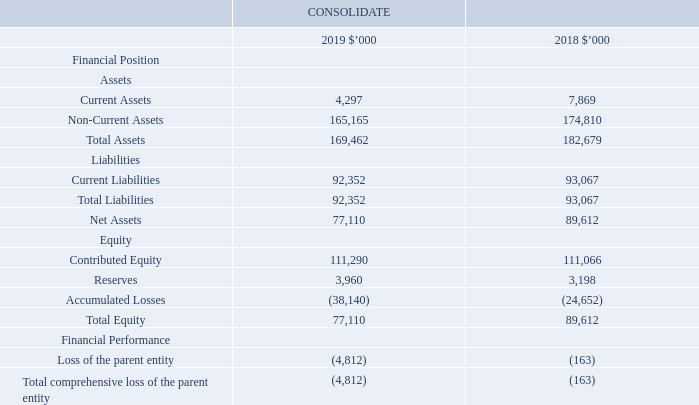Section 6: Our investments
This section outlines our group structure and includes information about our controlled and associated entities. It provides details of changes to these investments and their effect on our financial position and performance during the financial year. It also includes the results of our associated entities.
6.1 Parent entity disclosures
The accounting policies of the parent entity, iSelect Limited, which have been applied in determining the financial information shown below, are the same as those applied in the consolidated financial statements except for accounting for investments in subsidiaries which are measured at cost.
There are no contractual or contingent liabilities of the parent as at reporting date (2018: $nil). iSelect Limited has issued bank guarantees and letters of credit to third parties for various operational purposes. It is not expected these guarantees will be called on.
What is the current assets of the parent entity in 2019?
Answer scale should be: thousand. 4,297. What is the non-current assets of the parent entity in 2018?
Answer scale should be: thousand. 174,810. What is the loss of the parent entity in 2019?
Answer scale should be: thousand. 4,812. What is the current ratio of the parent entity in 2019? 4,297/92,352
Answer: 0.05. What is the debts to assets ratio of the parent entity in 2018? 93,067/182,679
Answer: 0.51. What is the percentage change in the total comprehensive loss of the parent entity from 2018 to 2019?
Answer scale should be: percent. (4,812-163)/163
Answer: 2852.15. 